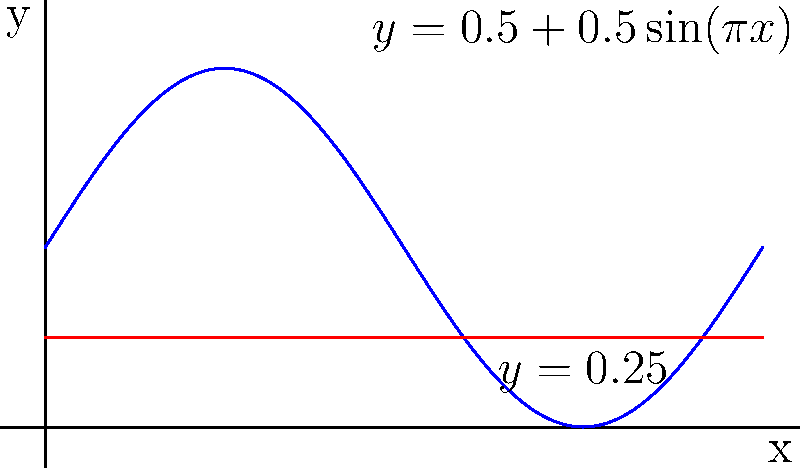Imagine you're designing a special microphone for a Neil Diamond tribute concert. The microphone's shape is formed by rotating the region bounded by $y=0.5+0.5\sin(\pi x)$, $y=0.25$, and the y-axis around the x-axis from $x=0$ to $x=2$. What is the volume of this microphone-shaped solid of revolution in cubic units? Let's approach this step-by-step:

1) The volume of a solid of revolution is given by the formula:
   $$V = \pi \int_a^b [R(x)^2 - r(x)^2] dx$$
   where $R(x)$ is the outer function and $r(x)$ is the inner function.

2) In this case:
   $R(x) = 0.5 + 0.5\sin(\pi x)$
   $r(x) = 0.25$
   $a = 0$ and $b = 2$

3) Substituting into the formula:
   $$V = \pi \int_0^2 [(0.5 + 0.5\sin(\pi x))^2 - 0.25^2] dx$$

4) Expand the squared term:
   $$V = \pi \int_0^2 [0.25 + 0.5\sin(\pi x) + 0.25\sin^2(\pi x) - 0.0625] dx$$

5) Simplify:
   $$V = \pi \int_0^2 [0.1875 + 0.5\sin(\pi x) + 0.25\sin^2(\pi x)] dx$$

6) Integrate each term:
   - $\int 0.1875 dx = 0.1875x$
   - $\int 0.5\sin(\pi x) dx = -\frac{0.5}{\pi}\cos(\pi x)$
   - $\int 0.25\sin^2(\pi x) dx = \frac{x}{8} - \frac{1}{8\pi}\sin(2\pi x)$

7) Evaluate from 0 to 2:
   $$V = \pi [(0.1875 \cdot 2) + 0 + (\frac{2}{8} - 0)]$$

8) Simplify:
   $$V = \pi (0.375 + 0.25) = 0.625\pi$$

Therefore, the volume of the microphone-shaped solid is $0.625\pi$ cubic units.
Answer: $0.625\pi$ cubic units 